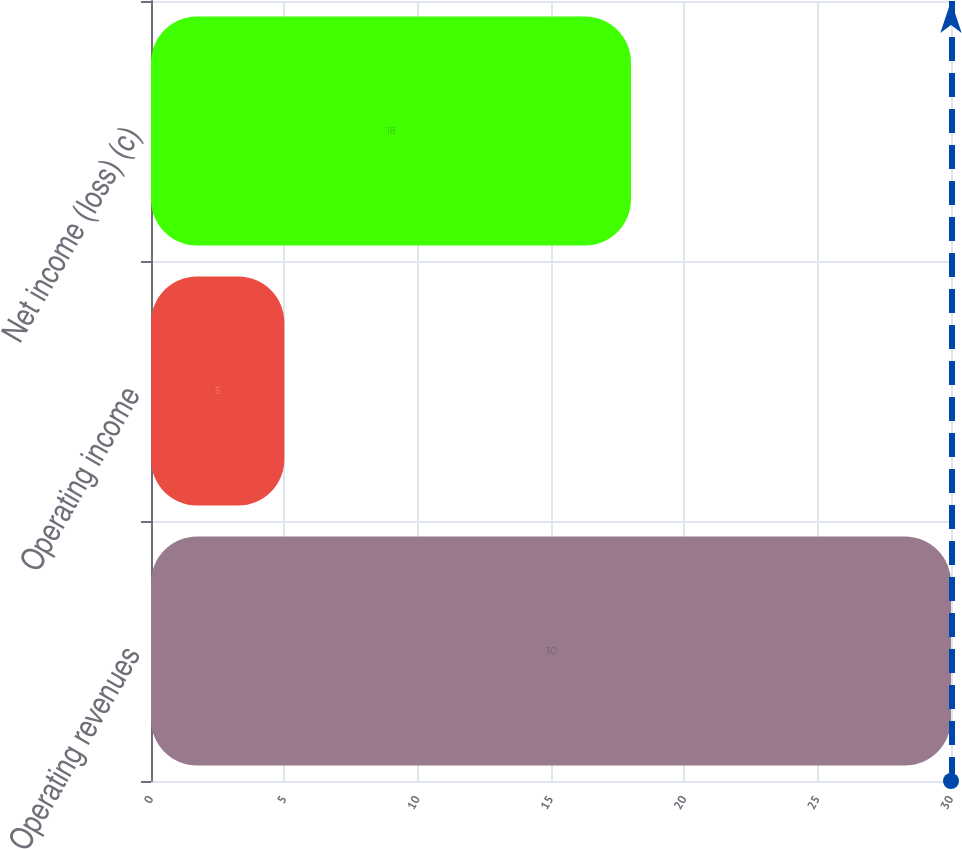Convert chart to OTSL. <chart><loc_0><loc_0><loc_500><loc_500><bar_chart><fcel>Operating revenues<fcel>Operating income<fcel>Net income (loss) (c)<nl><fcel>30<fcel>5<fcel>18<nl></chart> 